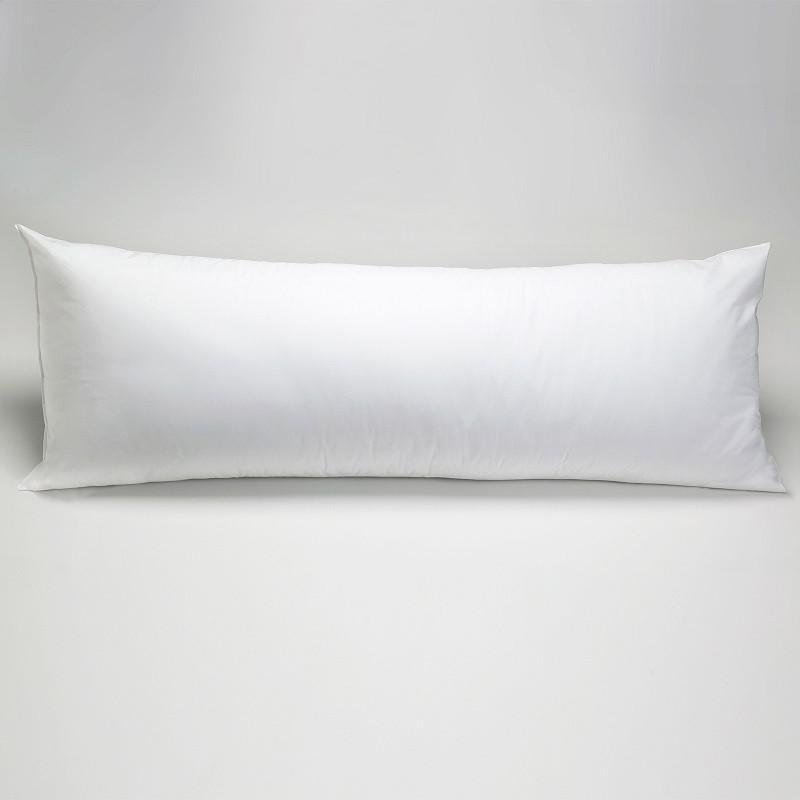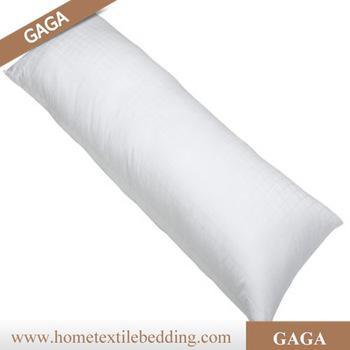The first image is the image on the left, the second image is the image on the right. Given the left and right images, does the statement "The pillow on the right is white and displayed horizontally, and the pillow on the left is white and displayed at some angle instead of horizontally." hold true? Answer yes or no. No. The first image is the image on the left, the second image is the image on the right. Evaluate the accuracy of this statement regarding the images: "The left and right image contains the same number of long white body pillows.". Is it true? Answer yes or no. Yes. 